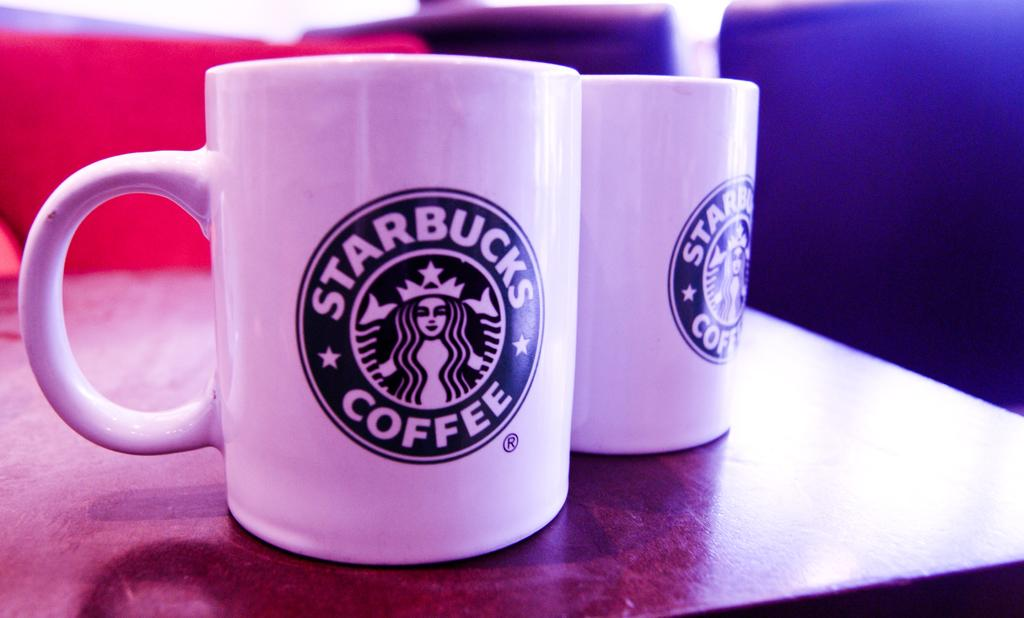<image>
Relay a brief, clear account of the picture shown. Two white Starbucks mug are sitting together on a table. 